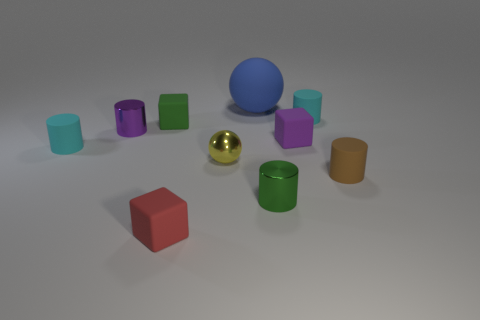What material is the green thing that is behind the tiny cyan matte thing that is in front of the small purple thing that is on the right side of the green matte thing?
Keep it short and to the point. Rubber. What color is the small cylinder that is behind the purple shiny cylinder?
Provide a succinct answer. Cyan. Is there anything else that is the same shape as the large blue thing?
Offer a terse response. Yes. There is a cyan matte cylinder behind the tiny cube behind the small purple rubber object; what size is it?
Offer a terse response. Small. Are there the same number of small green cylinders that are behind the small brown thing and green matte objects that are on the right side of the tiny red thing?
Ensure brevity in your answer.  Yes. Is there anything else that has the same size as the blue matte object?
Offer a terse response. No. What is the color of the ball that is the same material as the purple cylinder?
Offer a very short reply. Yellow. Is the tiny purple cube made of the same material as the small cyan cylinder that is to the left of the purple metallic cylinder?
Your response must be concise. Yes. There is a shiny thing that is both right of the red rubber cube and behind the tiny green metal cylinder; what is its color?
Offer a very short reply. Yellow. What number of cylinders are large purple rubber objects or tiny yellow objects?
Make the answer very short. 0. 